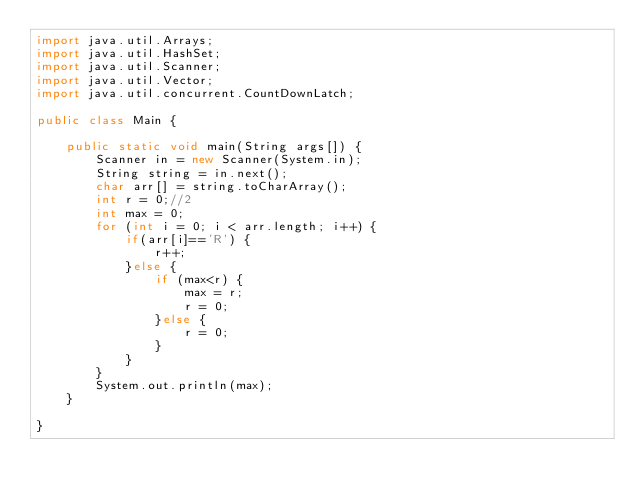Convert code to text. <code><loc_0><loc_0><loc_500><loc_500><_Java_>import java.util.Arrays;
import java.util.HashSet;
import java.util.Scanner;
import java.util.Vector;
import java.util.concurrent.CountDownLatch;

public class Main {
	
	public static void main(String args[]) {
		Scanner in = new Scanner(System.in);
		String string = in.next();
		char arr[] = string.toCharArray();
		int r = 0;//2
		int max = 0;
		for (int i = 0; i < arr.length; i++) {
			if(arr[i]=='R') {
				r++;
			}else {
				if (max<r) {
					max = r;
					r = 0;
				}else {
					r = 0;
				}
			}
		}
		System.out.println(max);
	}

}</code> 